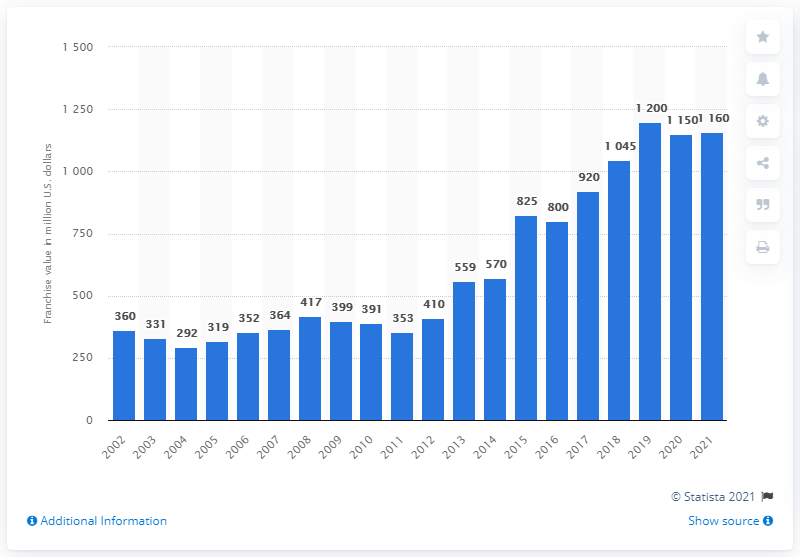List a handful of essential elements in this visual. The estimated value of the Cleveland Indians in 2021 was $1,160 million. 